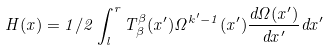Convert formula to latex. <formula><loc_0><loc_0><loc_500><loc_500>H ( x ) = 1 / 2 \int ^ { r } _ { l } T ^ { \beta } _ { \beta } ( x ^ { \prime } ) \Omega ^ { k ^ { \prime } - 1 } ( x ^ { \prime } ) \frac { d \Omega ( x ^ { \prime } ) } { d x ^ { \prime } } d x ^ { \prime }</formula> 